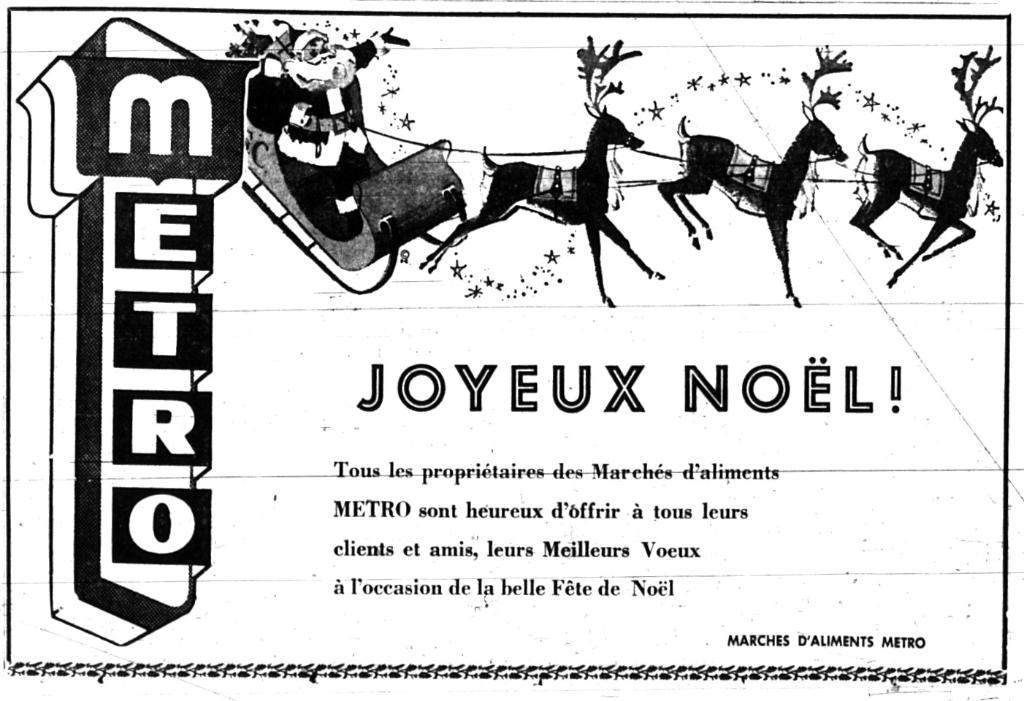What type of animals can be seen in the image? There are animals in the image, but their specific type cannot be determined from the provided facts. Who is also present in the image besides the animals? Santa is present in the image. What additional information is provided on the image? There is text written on the image. What is the color scheme of the image? The image is in black and white. What type of string is being used by the spy in the image? There is no spy or string present in the image; it features animals and Santa. What type of fireman equipment can be seen in the image? There is no fireman or fireman equipment present in the image. 